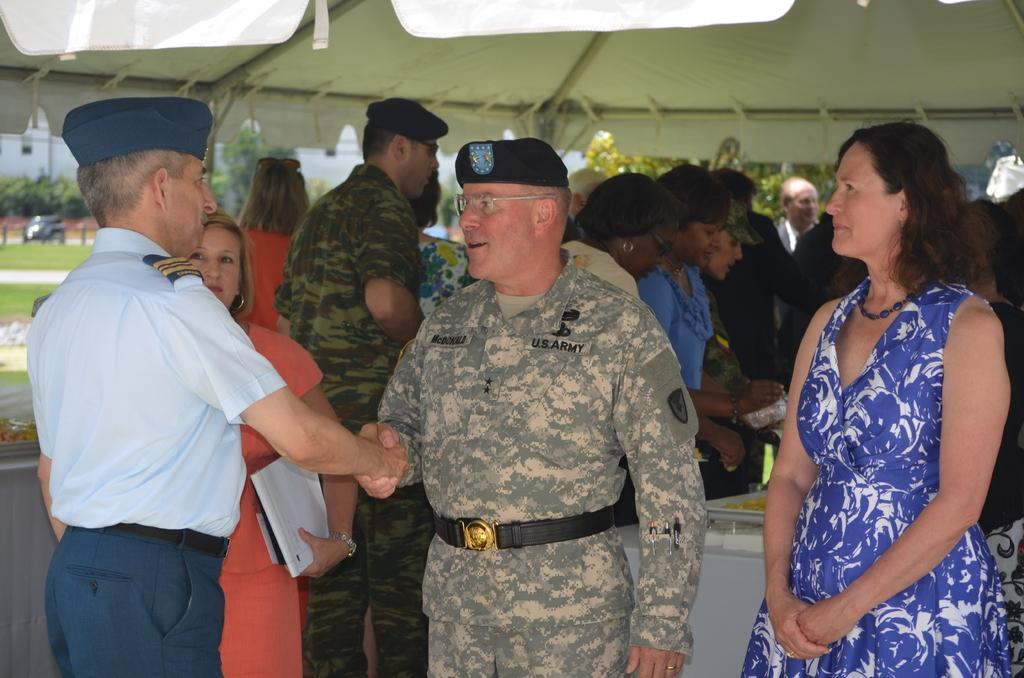How many people are in the image? There are people in the image, but the exact number is not specified. What is the woman holding in the image? The woman is holding a book with her hand. What type of shelter is visible in the image? There is a tent in the image. What type of ground surface is present in the image? Grass is present in the image. What type of vehicle is in the image? There is a car in the image. What type of vegetation is visible in the image? Plants and trees are present in the image. What type of structure is visible in the image? There is a wall in the image. What type of objects are in the image? There are objects in the image, but their specific nature is not specified. What type of carriage is being used for learning and education in the image? There is no carriage present in the image, and the image does not depict any learning or education activities. 